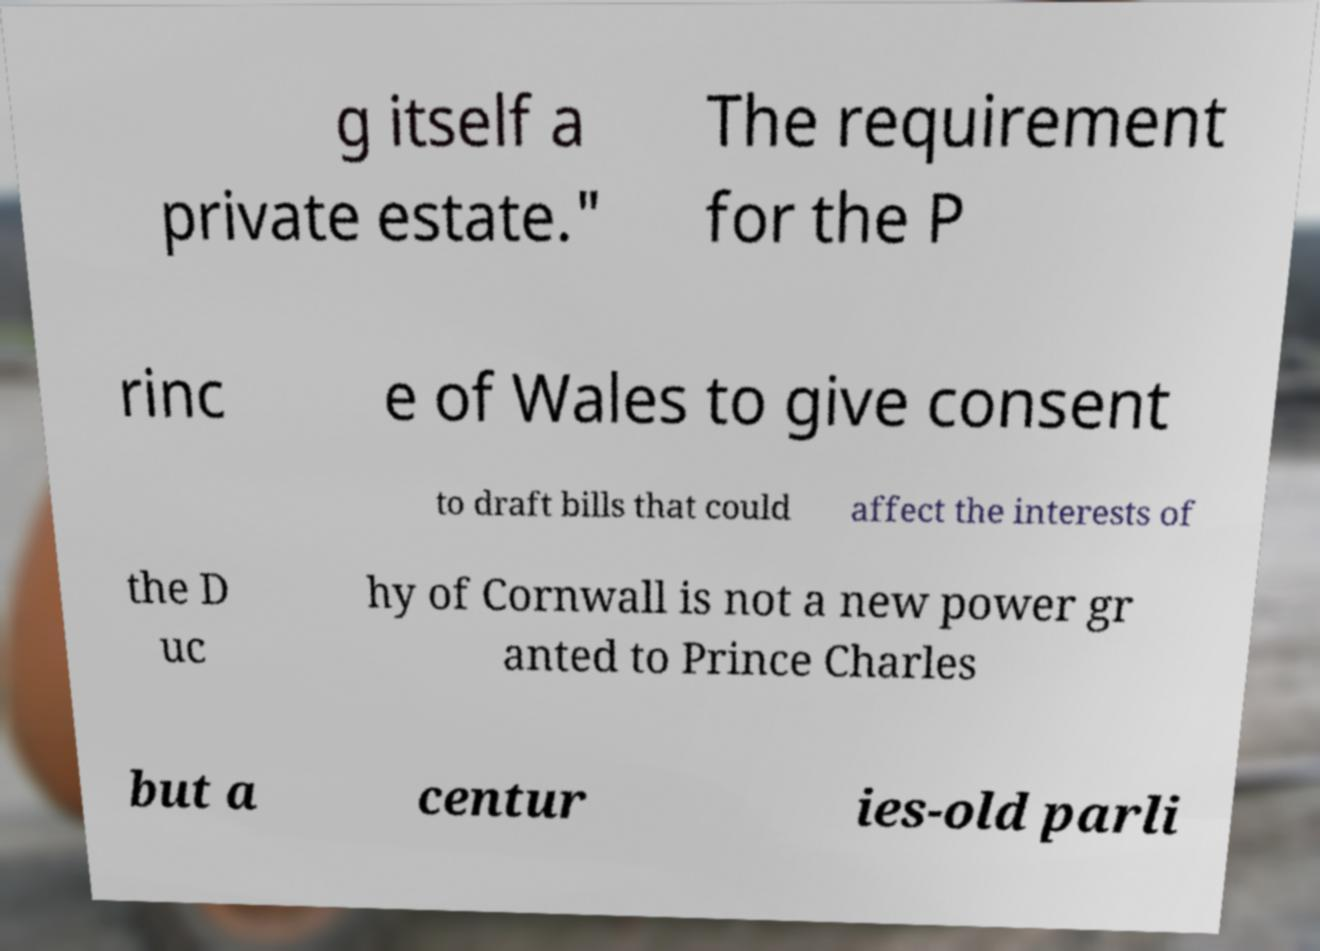Please identify and transcribe the text found in this image. g itself a private estate." The requirement for the P rinc e of Wales to give consent to draft bills that could affect the interests of the D uc hy of Cornwall is not a new power gr anted to Prince Charles but a centur ies-old parli 